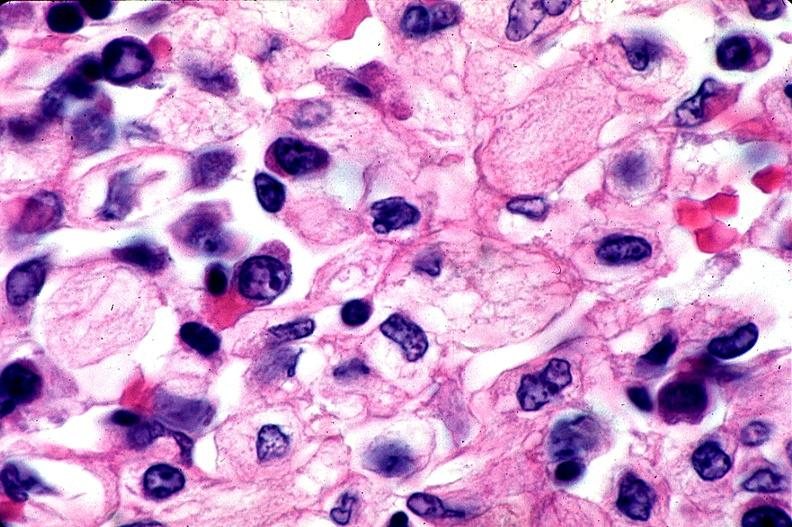s hematologic present?
Answer the question using a single word or phrase. Yes 